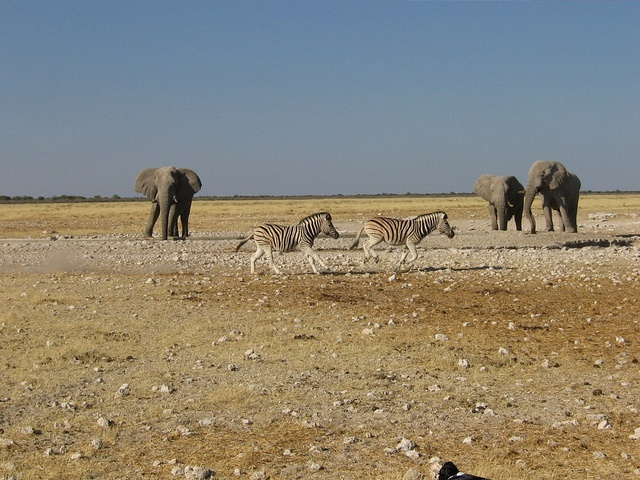Describe the objects in this image and their specific colors. I can see elephant in gray, black, and tan tones, zebra in gray, tan, and black tones, elephant in gray and black tones, zebra in gray, tan, and black tones, and elephant in gray and black tones in this image. 